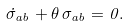<formula> <loc_0><loc_0><loc_500><loc_500>\dot { \sigma } _ { a b } + \theta \, \sigma _ { a b } = 0 .</formula> 